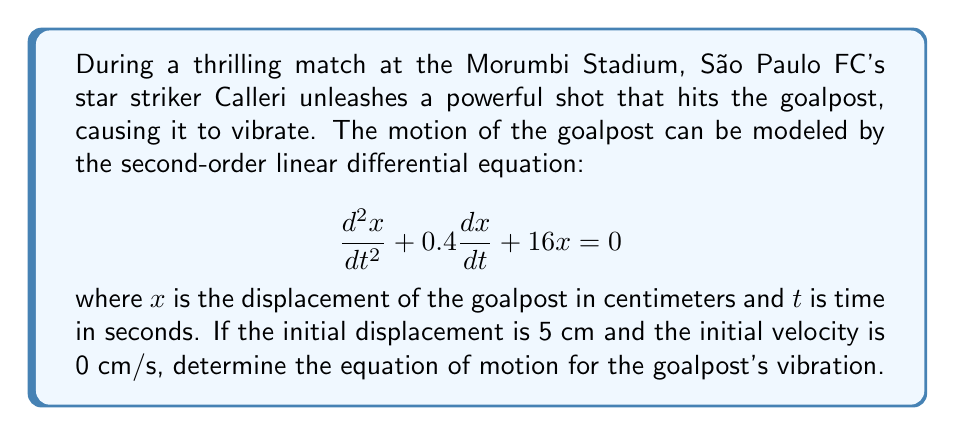Can you solve this math problem? To solve this problem, we need to follow these steps:

1) First, we identify that this is a damped harmonic oscillator equation in the form:
   $$\frac{d^2x}{dt^2} + 2\beta\frac{dx}{dt} + \omega_0^2x = 0$$
   where $2\beta = 0.4$ and $\omega_0^2 = 16$.

2) We calculate $\beta = 0.2$ and $\omega_0 = 4$.

3) To determine the type of damping, we compare $\beta$ and $\omega_0$:
   $\beta^2 = 0.04$ and $\omega_0^2 = 16$
   Since $\beta^2 < \omega_0^2$, this is an underdamped system.

4) For an underdamped system, the general solution is:
   $$x(t) = e^{-\beta t}(A\cos(\omega t) + B\sin(\omega t))$$
   where $\omega = \sqrt{\omega_0^2 - \beta^2} = \sqrt{16 - 0.04} = 3.9987 \approx 4$

5) Given the initial conditions:
   $x(0) = 5$ and $\frac{dx}{dt}(0) = 0$

6) Applying the first condition:
   $5 = A$

7) Taking the derivative of $x(t)$ and applying the second condition:
   $\frac{dx}{dt} = -\beta e^{-\beta t}(A\cos(\omega t) + B\sin(\omega t)) + e^{-\beta t}(-A\omega\sin(\omega t) + B\omega\cos(\omega t))$
   $0 = -0.2A + B\omega$
   $B = \frac{0.2A}{\omega} = \frac{0.2 \cdot 5}{4} = 0.25$

8) Therefore, the equation of motion is:
   $$x(t) = e^{-0.2t}(5\cos(4t) + 0.25\sin(4t))$$
Answer: $x(t) = e^{-0.2t}(5\cos(4t) + 0.25\sin(4t))$ 